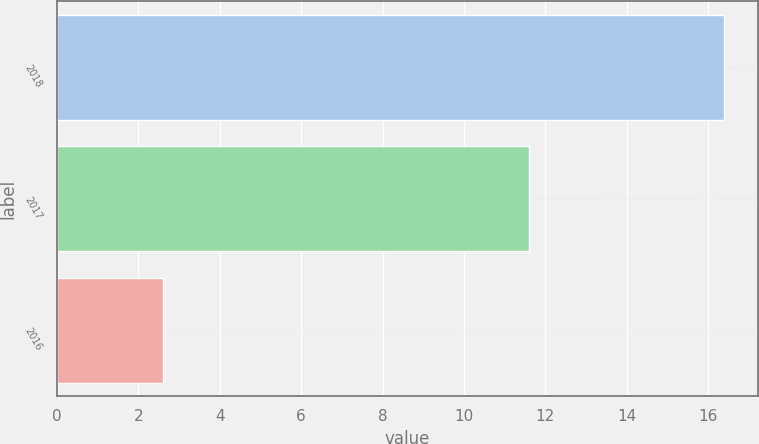Convert chart. <chart><loc_0><loc_0><loc_500><loc_500><bar_chart><fcel>2018<fcel>2017<fcel>2016<nl><fcel>16.4<fcel>11.6<fcel>2.6<nl></chart> 